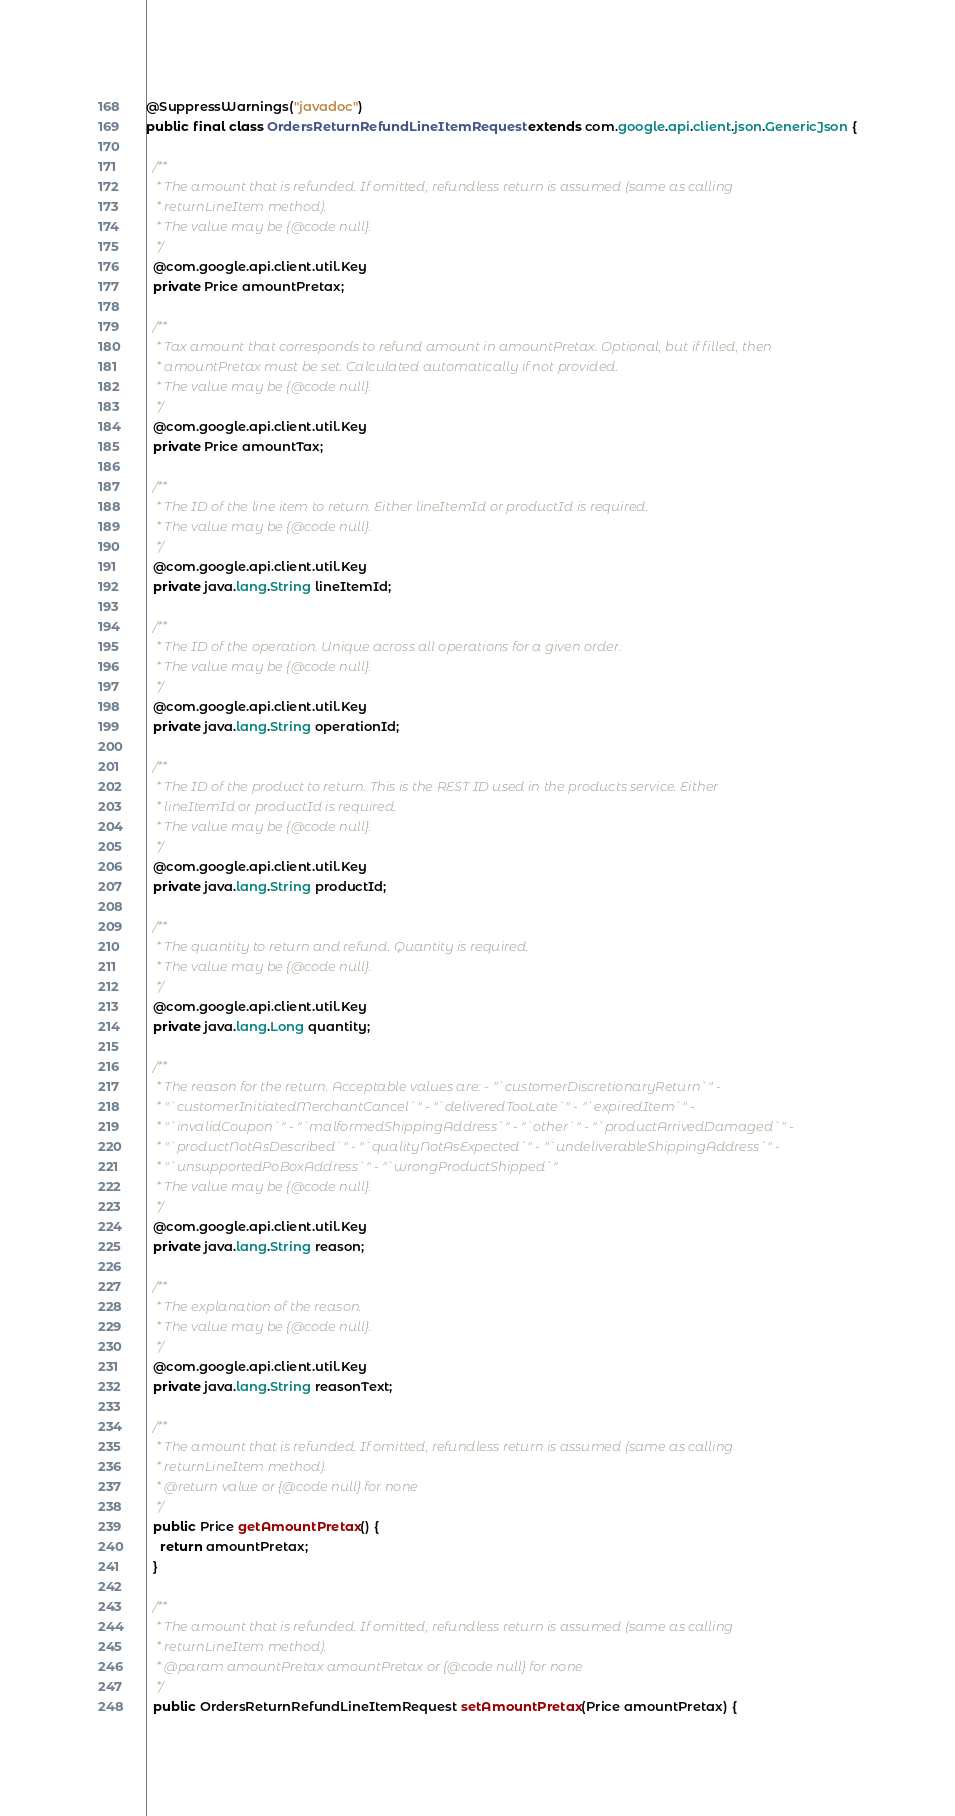<code> <loc_0><loc_0><loc_500><loc_500><_Java_>@SuppressWarnings("javadoc")
public final class OrdersReturnRefundLineItemRequest extends com.google.api.client.json.GenericJson {

  /**
   * The amount that is refunded. If omitted, refundless return is assumed (same as calling
   * returnLineItem method).
   * The value may be {@code null}.
   */
  @com.google.api.client.util.Key
  private Price amountPretax;

  /**
   * Tax amount that corresponds to refund amount in amountPretax. Optional, but if filled, then
   * amountPretax must be set. Calculated automatically if not provided.
   * The value may be {@code null}.
   */
  @com.google.api.client.util.Key
  private Price amountTax;

  /**
   * The ID of the line item to return. Either lineItemId or productId is required.
   * The value may be {@code null}.
   */
  @com.google.api.client.util.Key
  private java.lang.String lineItemId;

  /**
   * The ID of the operation. Unique across all operations for a given order.
   * The value may be {@code null}.
   */
  @com.google.api.client.util.Key
  private java.lang.String operationId;

  /**
   * The ID of the product to return. This is the REST ID used in the products service. Either
   * lineItemId or productId is required.
   * The value may be {@code null}.
   */
  @com.google.api.client.util.Key
  private java.lang.String productId;

  /**
   * The quantity to return and refund. Quantity is required.
   * The value may be {@code null}.
   */
  @com.google.api.client.util.Key
  private java.lang.Long quantity;

  /**
   * The reason for the return. Acceptable values are: - "`customerDiscretionaryReturn`" -
   * "`customerInitiatedMerchantCancel`" - "`deliveredTooLate`" - "`expiredItem`" -
   * "`invalidCoupon`" - "`malformedShippingAddress`" - "`other`" - "`productArrivedDamaged`" -
   * "`productNotAsDescribed`" - "`qualityNotAsExpected`" - "`undeliverableShippingAddress`" -
   * "`unsupportedPoBoxAddress`" - "`wrongProductShipped`"
   * The value may be {@code null}.
   */
  @com.google.api.client.util.Key
  private java.lang.String reason;

  /**
   * The explanation of the reason.
   * The value may be {@code null}.
   */
  @com.google.api.client.util.Key
  private java.lang.String reasonText;

  /**
   * The amount that is refunded. If omitted, refundless return is assumed (same as calling
   * returnLineItem method).
   * @return value or {@code null} for none
   */
  public Price getAmountPretax() {
    return amountPretax;
  }

  /**
   * The amount that is refunded. If omitted, refundless return is assumed (same as calling
   * returnLineItem method).
   * @param amountPretax amountPretax or {@code null} for none
   */
  public OrdersReturnRefundLineItemRequest setAmountPretax(Price amountPretax) {</code> 